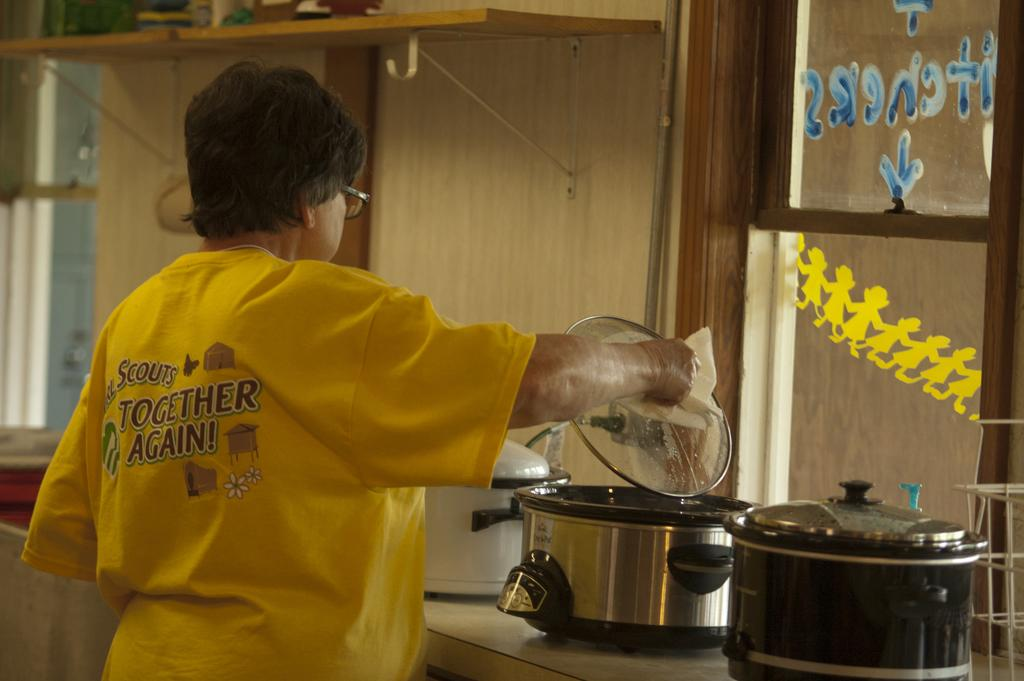Provide a one-sentence caption for the provided image. A person in a yellow shirt with Together Again using a crock pot. 